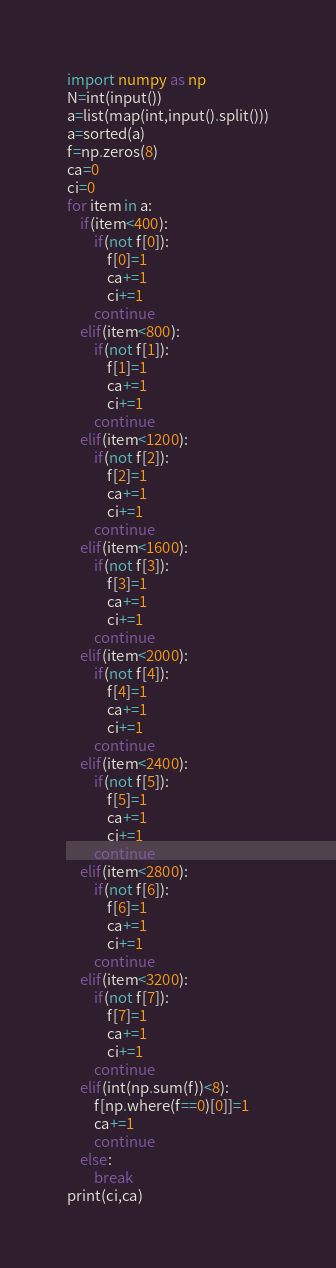<code> <loc_0><loc_0><loc_500><loc_500><_Python_>import numpy as np
N=int(input())
a=list(map(int,input().split()))
a=sorted(a)
f=np.zeros(8)
ca=0
ci=0
for item in a:
    if(item<400):
        if(not f[0]):
            f[0]=1
            ca+=1
            ci+=1
        continue
    elif(item<800):
        if(not f[1]):
            f[1]=1
            ca+=1
            ci+=1
        continue
    elif(item<1200):
        if(not f[2]):
            f[2]=1
            ca+=1
            ci+=1
        continue
    elif(item<1600):
        if(not f[3]):
            f[3]=1
            ca+=1
            ci+=1
        continue
    elif(item<2000):
        if(not f[4]):
            f[4]=1
            ca+=1
            ci+=1
        continue
    elif(item<2400):
        if(not f[5]):
            f[5]=1
            ca+=1
            ci+=1
        continue
    elif(item<2800):
        if(not f[6]):
            f[6]=1
            ca+=1
            ci+=1
        continue
    elif(item<3200):
        if(not f[7]):
            f[7]=1
            ca+=1
            ci+=1
        continue
    elif(int(np.sum(f))<8):
        f[np.where(f==0)[0]]=1
        ca+=1
        continue
    else:
        break
print(ci,ca)</code> 